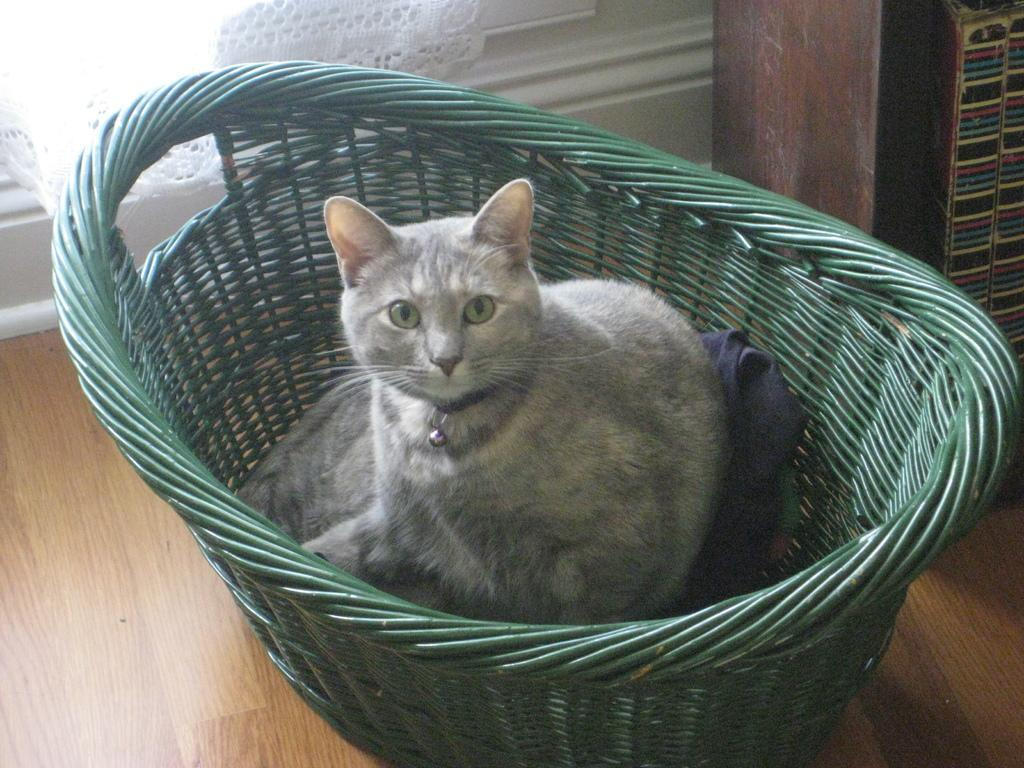What is located in the center of the picture? There is a green basket in the center of the picture. What is inside the green basket? A cat is inside the basket. What can be seen at the top left of the image? There is a curtain and a window at the top left of the image. What is on the right side of the image? There is a wooden object on the right side of the image. What type of chicken is sitting on the wooden object in the image? There is no chicken present in the image; it features a green basket with a cat inside and a wooden object on the right side. 